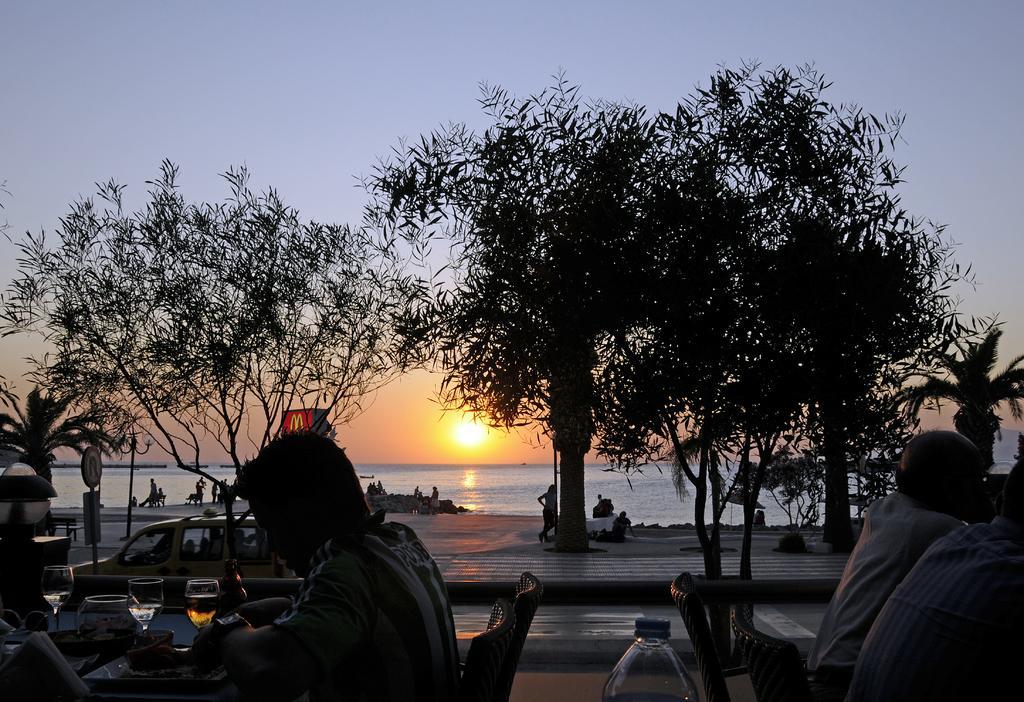How would you summarize this image in a sentence or two? In the image there are people standing and sitting in front of beach, in the front there are few people sitting around table with wine glasses and bottles on it, in the middle there is road with trees beside it and in the back there is sun in the sky. 